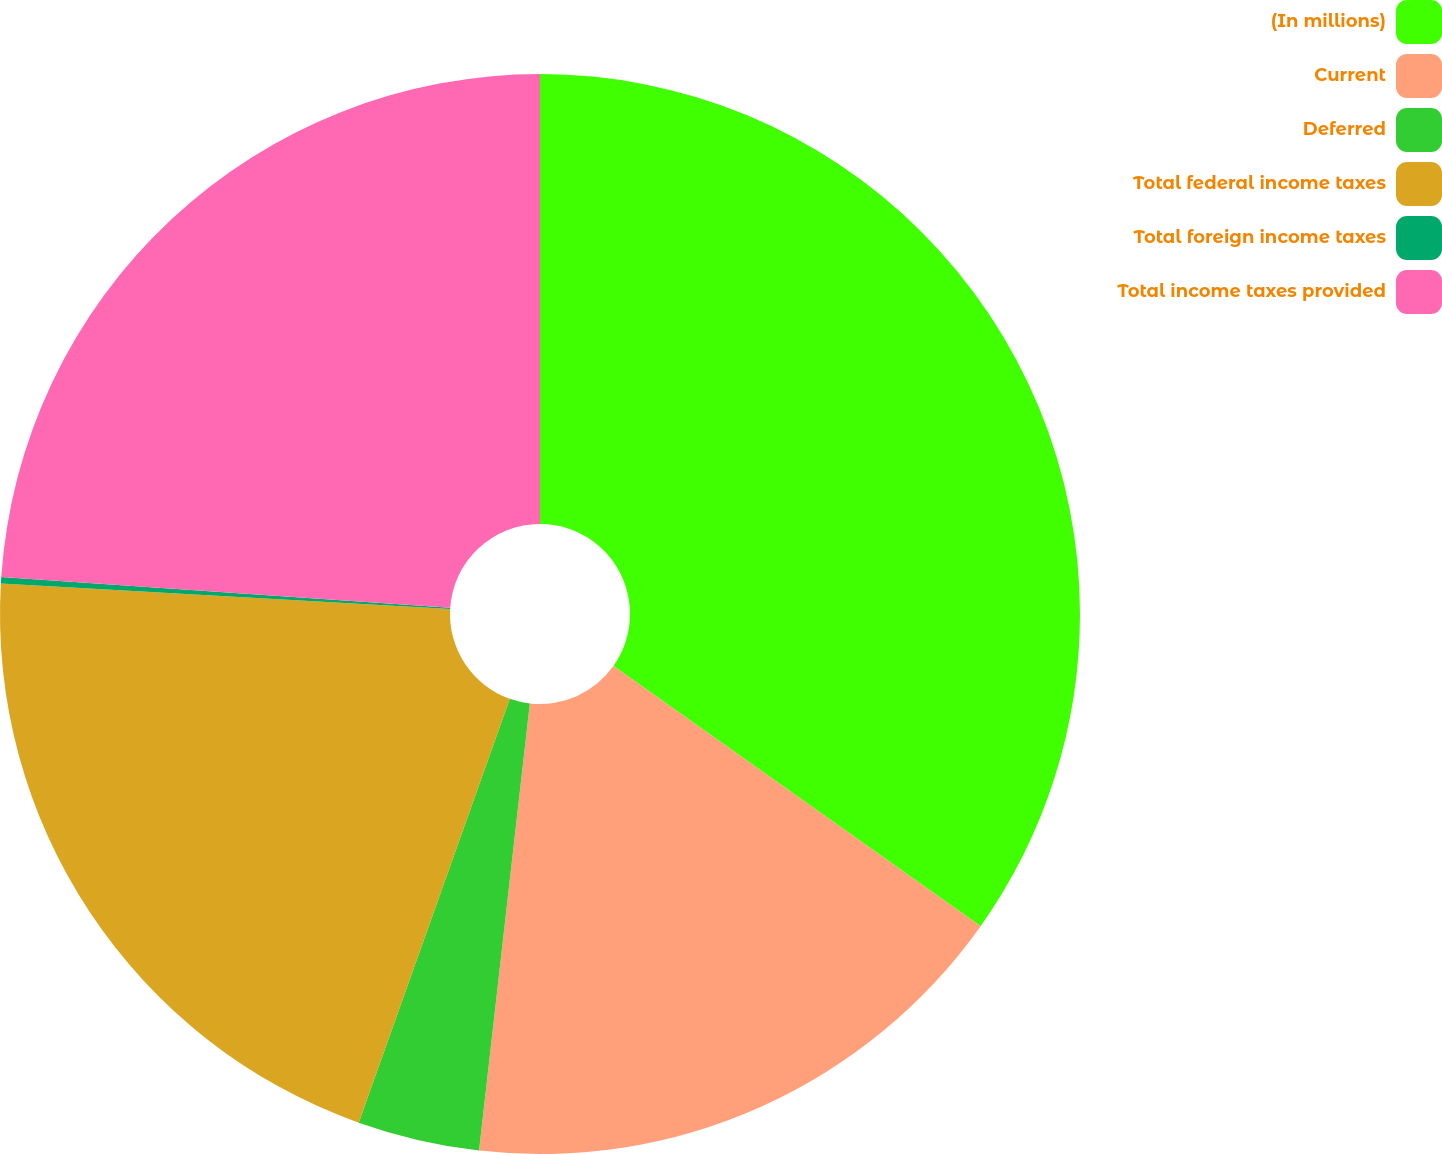Convert chart to OTSL. <chart><loc_0><loc_0><loc_500><loc_500><pie_chart><fcel>(In millions)<fcel>Current<fcel>Deferred<fcel>Total federal income taxes<fcel>Total foreign income taxes<fcel>Total income taxes provided<nl><fcel>34.81%<fcel>16.99%<fcel>3.65%<fcel>20.45%<fcel>0.19%<fcel>23.91%<nl></chart> 